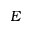<formula> <loc_0><loc_0><loc_500><loc_500>E</formula> 